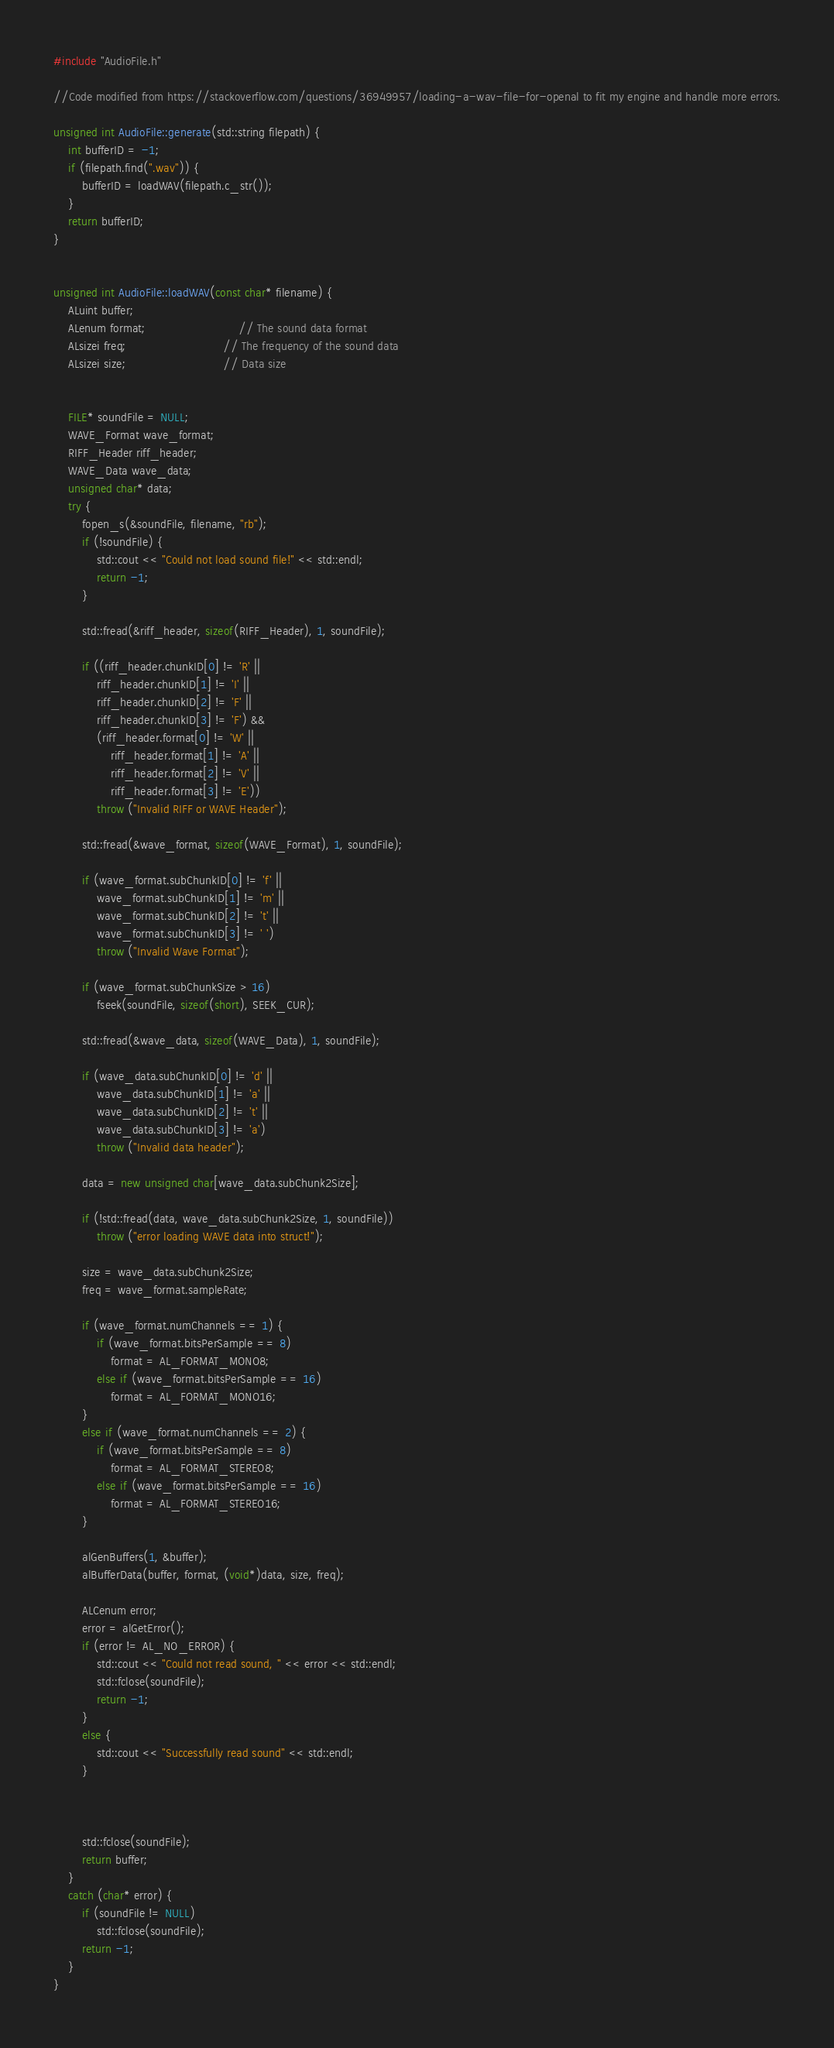<code> <loc_0><loc_0><loc_500><loc_500><_C++_>#include "AudioFile.h"

//Code modified from https://stackoverflow.com/questions/36949957/loading-a-wav-file-for-openal to fit my engine and handle more errors.

unsigned int AudioFile::generate(std::string filepath) {
	int bufferID = -1;
	if (filepath.find(".wav")) {
		bufferID = loadWAV(filepath.c_str());
	}
	return bufferID;
}


unsigned int AudioFile::loadWAV(const char* filename) {
	ALuint buffer;
	ALenum format;                          // The sound data format
	ALsizei freq;                           // The frequency of the sound data
	ALsizei size;                           // Data size


	FILE* soundFile = NULL;
	WAVE_Format wave_format;
	RIFF_Header riff_header;
	WAVE_Data wave_data;
	unsigned char* data;
	try {
		fopen_s(&soundFile, filename, "rb");
		if (!soundFile) {
			std::cout << "Could not load sound file!" << std::endl;
			return -1;
		}

		std::fread(&riff_header, sizeof(RIFF_Header), 1, soundFile);

		if ((riff_header.chunkID[0] != 'R' ||
			riff_header.chunkID[1] != 'I' ||
			riff_header.chunkID[2] != 'F' ||
			riff_header.chunkID[3] != 'F') &&
			(riff_header.format[0] != 'W' ||
				riff_header.format[1] != 'A' ||
				riff_header.format[2] != 'V' ||
				riff_header.format[3] != 'E'))
			throw ("Invalid RIFF or WAVE Header");

		std::fread(&wave_format, sizeof(WAVE_Format), 1, soundFile);

		if (wave_format.subChunkID[0] != 'f' ||
			wave_format.subChunkID[1] != 'm' ||
			wave_format.subChunkID[2] != 't' ||
			wave_format.subChunkID[3] != ' ')
			throw ("Invalid Wave Format");

		if (wave_format.subChunkSize > 16)
			fseek(soundFile, sizeof(short), SEEK_CUR);

		std::fread(&wave_data, sizeof(WAVE_Data), 1, soundFile);

		if (wave_data.subChunkID[0] != 'd' ||
			wave_data.subChunkID[1] != 'a' ||
			wave_data.subChunkID[2] != 't' ||
			wave_data.subChunkID[3] != 'a')
			throw ("Invalid data header");

		data = new unsigned char[wave_data.subChunk2Size];

		if (!std::fread(data, wave_data.subChunk2Size, 1, soundFile))
			throw ("error loading WAVE data into struct!");

		size = wave_data.subChunk2Size;
		freq = wave_format.sampleRate;

		if (wave_format.numChannels == 1) {
			if (wave_format.bitsPerSample == 8)
				format = AL_FORMAT_MONO8;
			else if (wave_format.bitsPerSample == 16)
				format = AL_FORMAT_MONO16;
		}
		else if (wave_format.numChannels == 2) {
			if (wave_format.bitsPerSample == 8)
				format = AL_FORMAT_STEREO8;
			else if (wave_format.bitsPerSample == 16)
				format = AL_FORMAT_STEREO16;
		}

		alGenBuffers(1, &buffer);
		alBufferData(buffer, format, (void*)data, size, freq);	

		ALCenum error;
		error = alGetError();
		if (error != AL_NO_ERROR) {
			std::cout << "Could not read sound, " << error << std::endl;
			std::fclose(soundFile);
			return -1;
		}
		else {
			std::cout << "Successfully read sound" << std::endl;
		}
		


		std::fclose(soundFile);
		return buffer;
	}
	catch (char* error) {
		if (soundFile != NULL)
			std::fclose(soundFile);
		return -1;
	}
}
</code> 